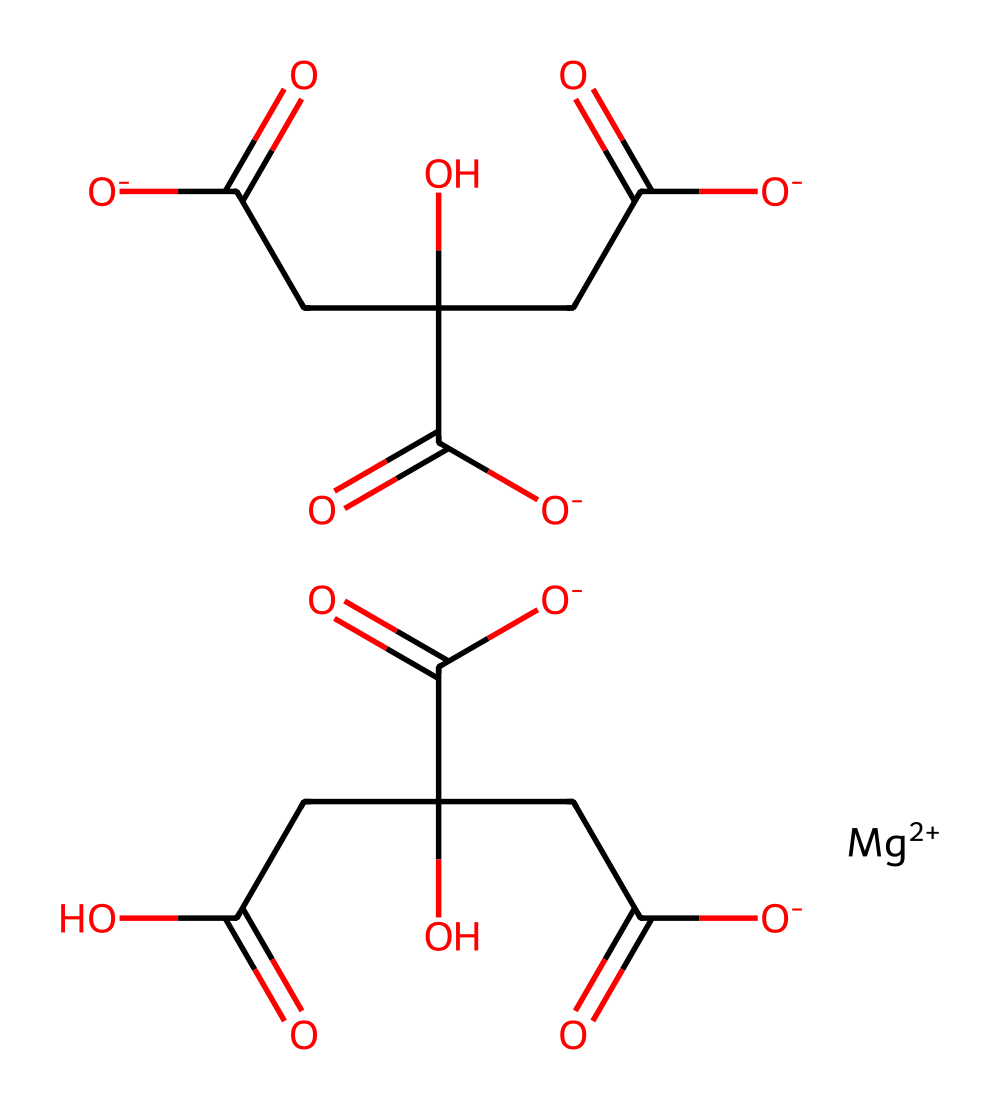What is the main cation in magnesium citrate? The SMILES representation indicates the presence of "[Mg++]", which refers to magnesium ions. Therefore, the main cation is magnesium.
Answer: magnesium How many total carboxyl groups are present in magnesium citrate? In the SMILES structure, "C(=O)" appears multiple times, indicating carboxylic acid functional groups. Counting these within the molecule, there are three carboxyl groups.
Answer: three What is the typical function of magnesium citrate in recovery beverages? Magnesium citrate is commonly used for its electrolyte properties, particularly in aiding hydration and muscle function.
Answer: electrolyte How many oxygen atoms are present in the magnesium citrate structure? By analyzing the SMILES representation, the oxygen "O" atoms can be counted. There are a total of eight oxygen atoms in the structure.
Answer: eight What type of chemical compound is magnesium citrate classified as? Magnesium citrate is classified as a citrate, which falls under organic salts and is considered an electrolyte. This classification is based on its ionic nature and the presence of carboxyl groups.
Answer: citrate How does the presence of magnesium affect muscle contractions in the body? Magnesium aids in the function of muscles by acting as a cofactor in enzymatic reactions necessary for muscle contraction and relaxation. Its presence can help regulate calcium levels in muscles.
Answer: cofactor 